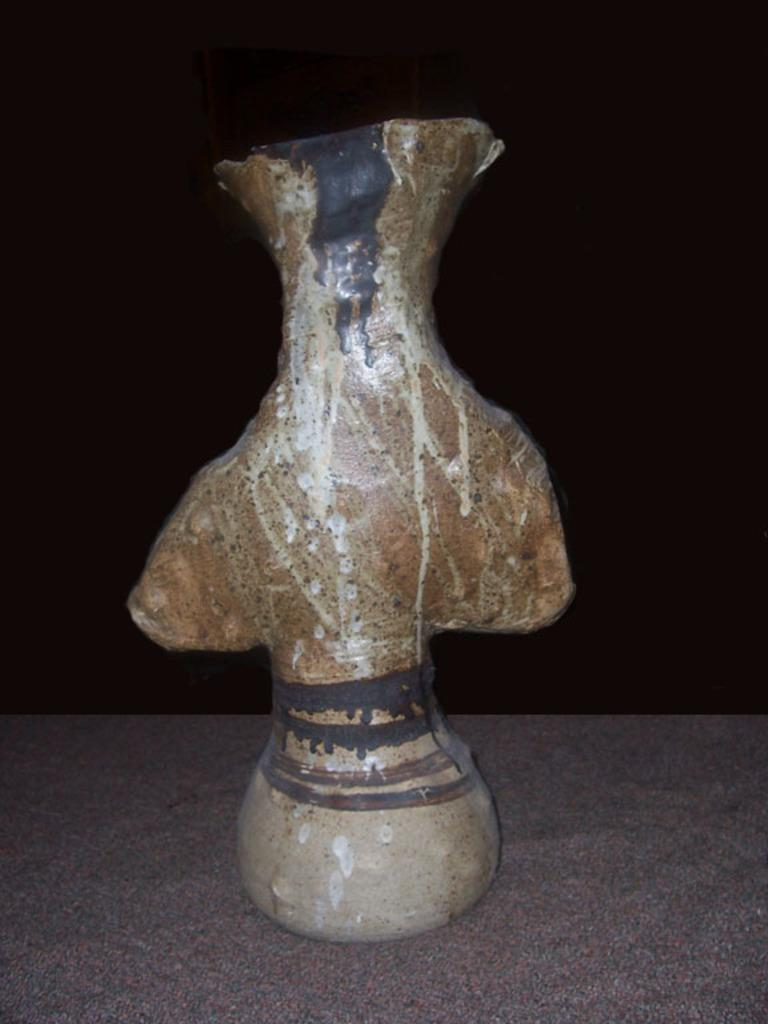What can be seen in the image? There is an object in the image. What is the color of the surface the object is placed on? The surface is gray and brown in color. What are the colors of the object itself? The object is in brown and cream color. How would you describe the background of the image? The background of the image is dark. How does the object participate in the competition in the image? There is no competition present in the image, so the object cannot participate in one. 